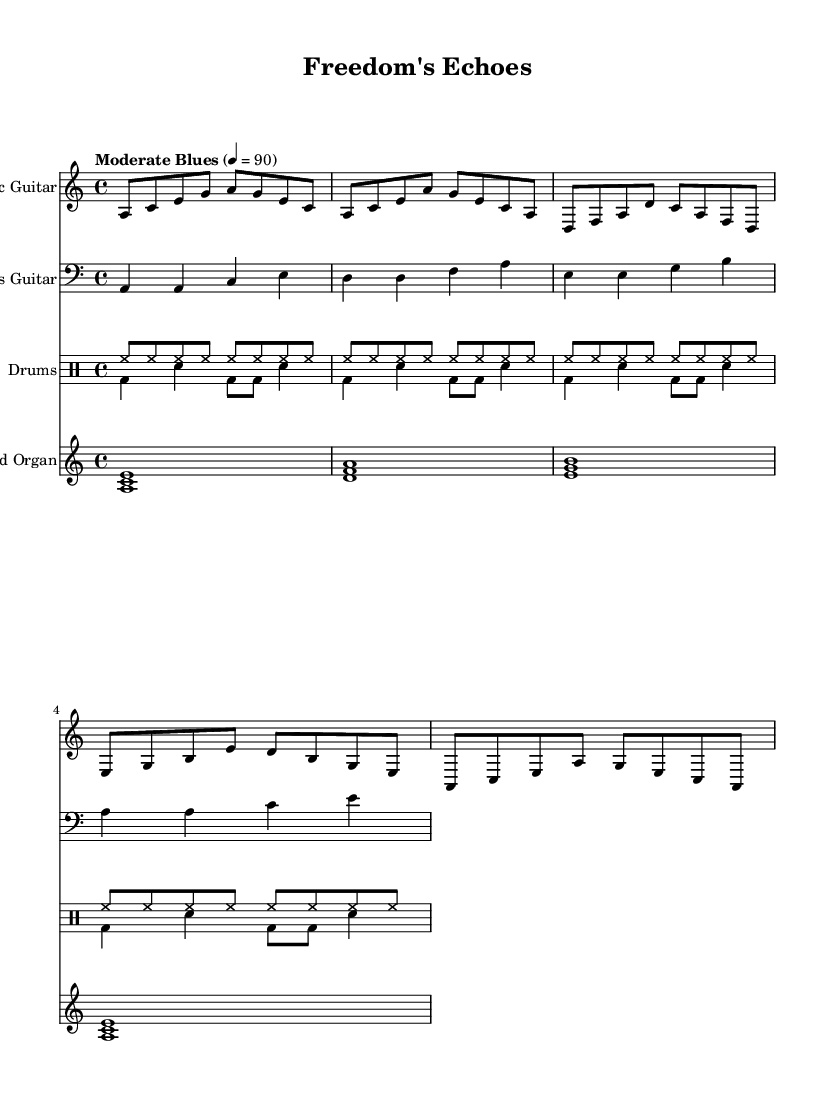What is the time signature of this music? The time signature is indicated at the beginning of the sheet music. It shows a 4 over 4, meaning there are four beats in each measure, and the quarter note gets one beat.
Answer: 4/4 What is the key signature of this music? The key signature is A minor, which has no sharps or flats; it is indicated at the beginning of the staff.
Answer: A minor What is the tempo marking of this piece? The tempo marking is indicated above the staff, stating "Moderate Blues" with a metronome marking of 90 beats per minute, which sets the pace for the performance.
Answer: Moderate Blues 4 = 90 How many instruments are notated in this score? By examining the score, we can count the individual staves: there are four distinct staves for the electric guitar, bass guitar, drums, and Hammond organ, indicating four instruments.
Answer: Four instruments Which instrument is playing the bass line? The bass line is written on the bass clef, which indicates it is played by the bass guitar, as specified in the staff name at the beginning.
Answer: Bass guitar What is the primary chord progression observed in the electric guitar part? Analyzing the notes played in sequence in the electric guitar part, we can identify chords built around A minor and D major, especially with note groupings reflecting common blues progressions, indicative of the style.
Answer: A minor to D major What rhythmic instrument pattern is employed throughout the score? The percussion section employs a consistent pattern with the hi-hat and bass drum in a repeating rhythmic structure. This is characteristic of the steady groove found in electric blues.
Answer: Hi-hat and bass drum pattern 